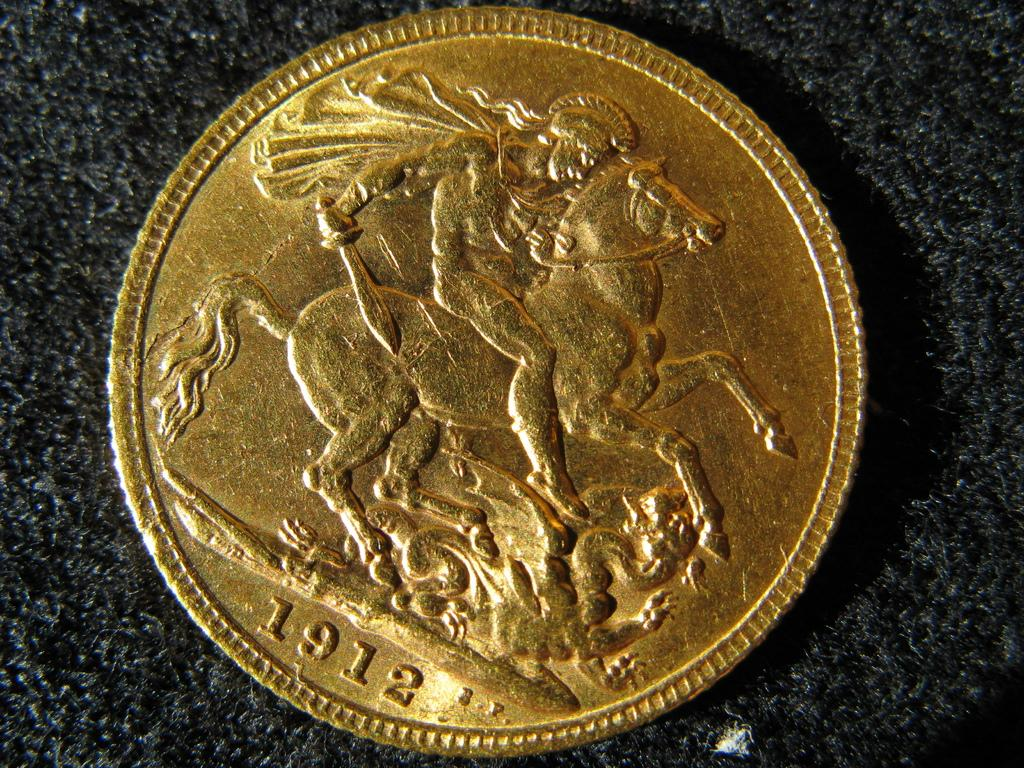Provide a one-sentence caption for the provided image. A single gold coin with a man riding a horse and the year 1912 on it. 